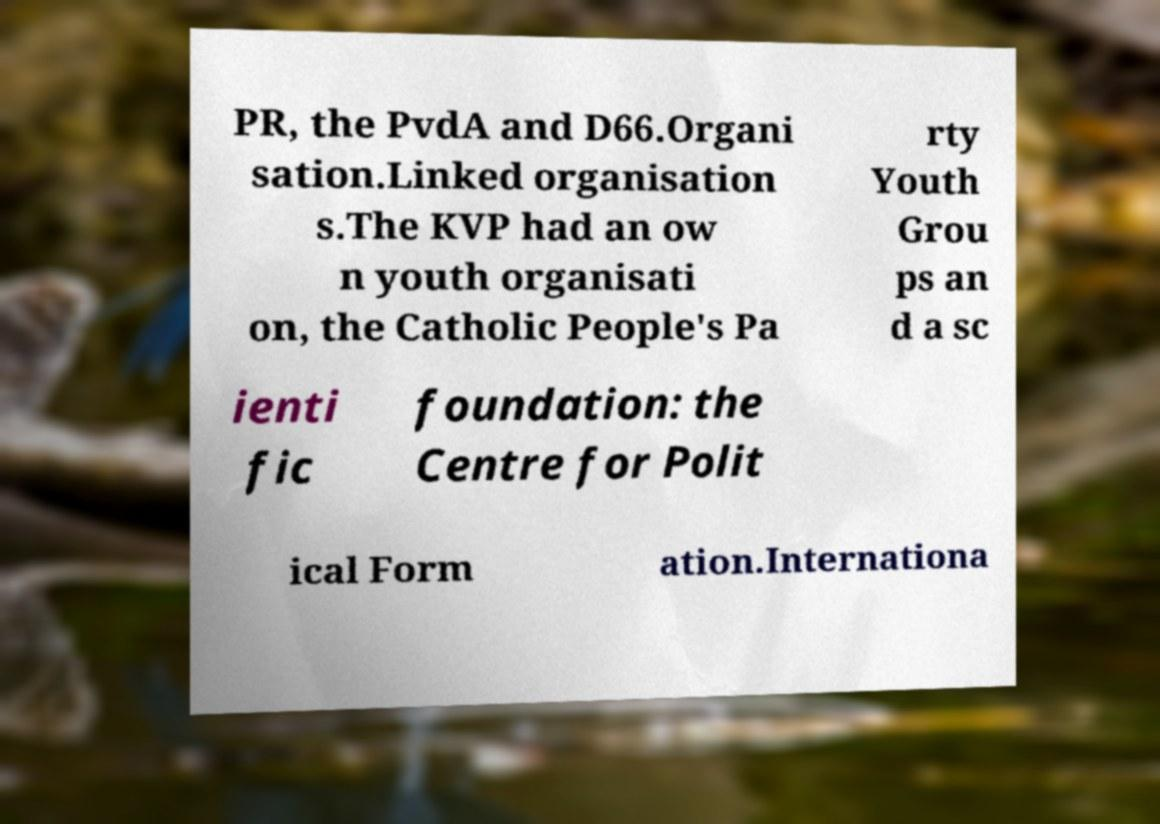Can you accurately transcribe the text from the provided image for me? PR, the PvdA and D66.Organi sation.Linked organisation s.The KVP had an ow n youth organisati on, the Catholic People's Pa rty Youth Grou ps an d a sc ienti fic foundation: the Centre for Polit ical Form ation.Internationa 